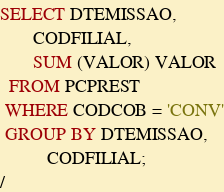<code> <loc_0><loc_0><loc_500><loc_500><_SQL_>SELECT DTEMISSAO,
       CODFILIAL,
       SUM (VALOR) VALOR
  FROM PCPREST
 WHERE CODCOB = 'CONV'
 GROUP BY DTEMISSAO,
          CODFILIAL;
/</code> 